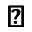Convert formula to latex. <formula><loc_0><loc_0><loc_500><loc_500>\pm b \triangle d o w n</formula> 